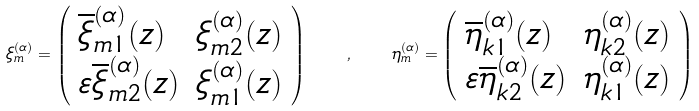<formula> <loc_0><loc_0><loc_500><loc_500>\xi _ { m } ^ { ( \alpha ) } = \left ( \begin{array} { l l } \overline { \xi } _ { m 1 } ^ { ( \alpha ) } ( z ) & \xi _ { m 2 } ^ { ( \alpha ) } ( z ) \\ \varepsilon \overline { \xi } _ { m 2 } ^ { ( \alpha ) } ( z ) & \xi _ { m 1 } ^ { ( \alpha ) } ( z ) \end{array} \right ) \quad , \quad \eta _ { m } ^ { ( \alpha ) } = \left ( \begin{array} { l l } \overline { \eta } _ { k 1 } ^ { ( \alpha ) } ( z ) & \eta _ { k 2 } ^ { ( \alpha ) } ( z ) \\ \varepsilon \overline { \eta } _ { k 2 } ^ { ( \alpha ) } ( z ) & \eta _ { k 1 } ^ { ( \alpha ) } ( z ) \end{array} \right )</formula> 